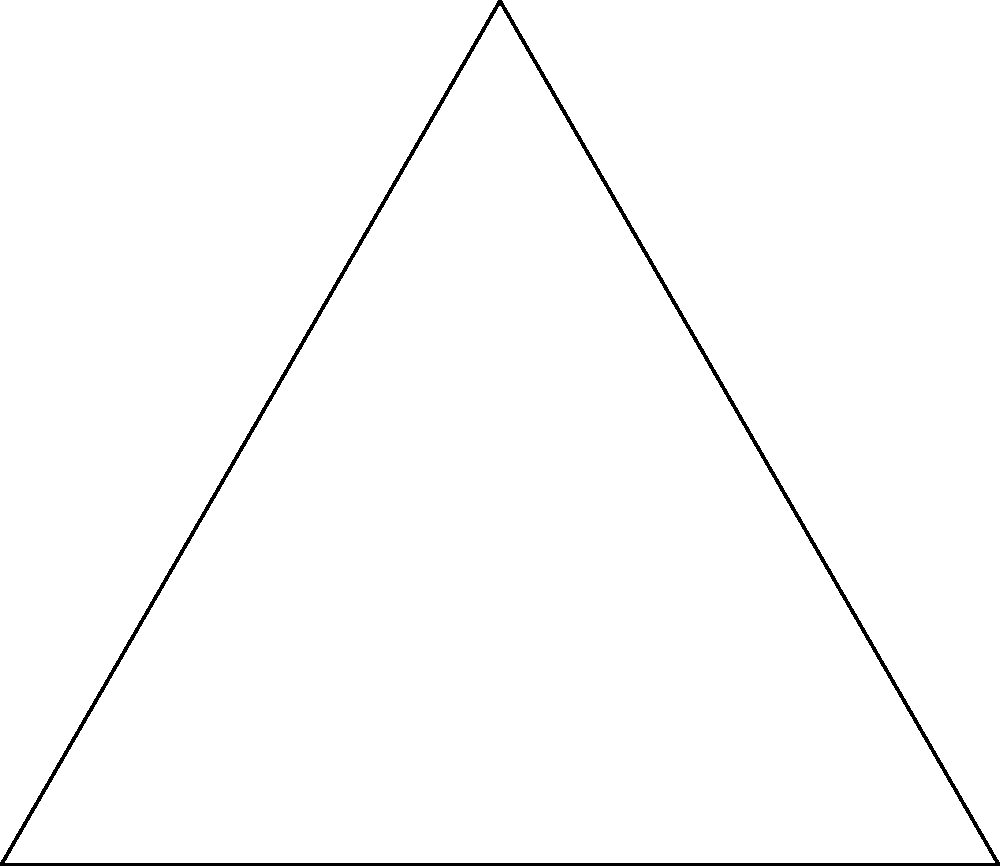In Farida Hossain's latest novel, a character discovers an ancient artifact in the shape of an equilateral triangle with a circle inscribed within it. If the side length of the equilateral triangle is 6 cm, what is the area of the inscribed circle? Round your answer to two decimal places. Let's approach this step-by-step:

1) In an equilateral triangle, the radius of the inscribed circle (r) is related to the side length (s) by the formula:

   $$r = \frac{s}{2\sqrt{3}}$$

2) We're given that the side length s = 6 cm. Let's substitute this into our formula:

   $$r = \frac{6}{2\sqrt{3}} = \frac{3}{\sqrt{3}}$$

3) To simplify this, we can rationalize the denominator:

   $$r = \frac{3}{\sqrt{3}} \cdot \frac{\sqrt{3}}{\sqrt{3}} = \frac{3\sqrt{3}}{3} = \sqrt{3} \approx 1.732$$

4) Now that we have the radius, we can calculate the area of the circle using the formula:

   $$A = \pi r^2$$

5) Substituting our value for r:

   $$A = \pi (\sqrt{3})^2 = 3\pi$$

6) Using π ≈ 3.14159, we get:

   $$A \approx 3 * 3.14159 \approx 9.42477$$

7) Rounding to two decimal places:

   $$A \approx 9.42 \text{ cm}^2$$
Answer: 9.42 cm² 